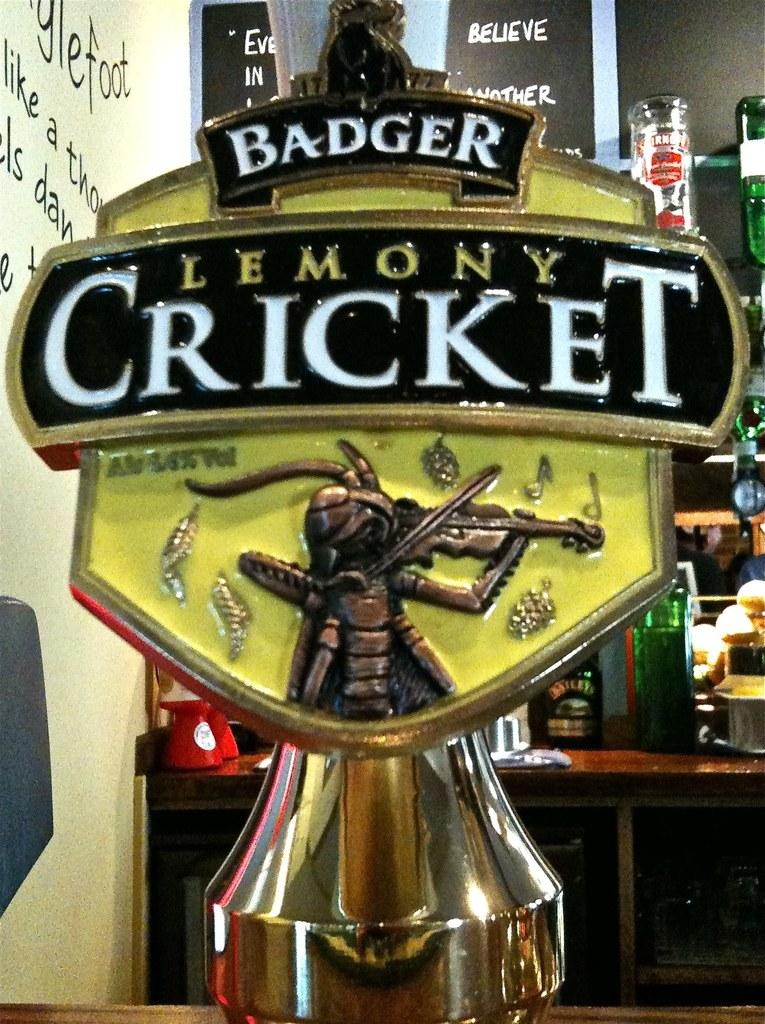What is attached to the stand on the table in the image? There is a hoarding attached to a stand on the table in the image. What can be seen in the background of the image? There are bottles and other objects arranged on shelves in the background, and there are paintings on the wall. What type of worm can be seen crawling on the hoarding in the image? There are no worms present in the image; it only features a hoarding attached to a stand on the table, shelves with bottles and other objects, and paintings on the wall. 